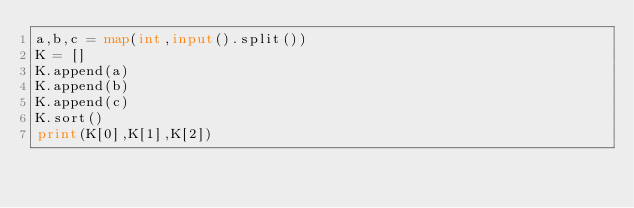Convert code to text. <code><loc_0><loc_0><loc_500><loc_500><_Python_>a,b,c = map(int,input().split())
K = []
K.append(a)
K.append(b)
K.append(c)
K.sort()
print(K[0],K[1],K[2])
</code> 